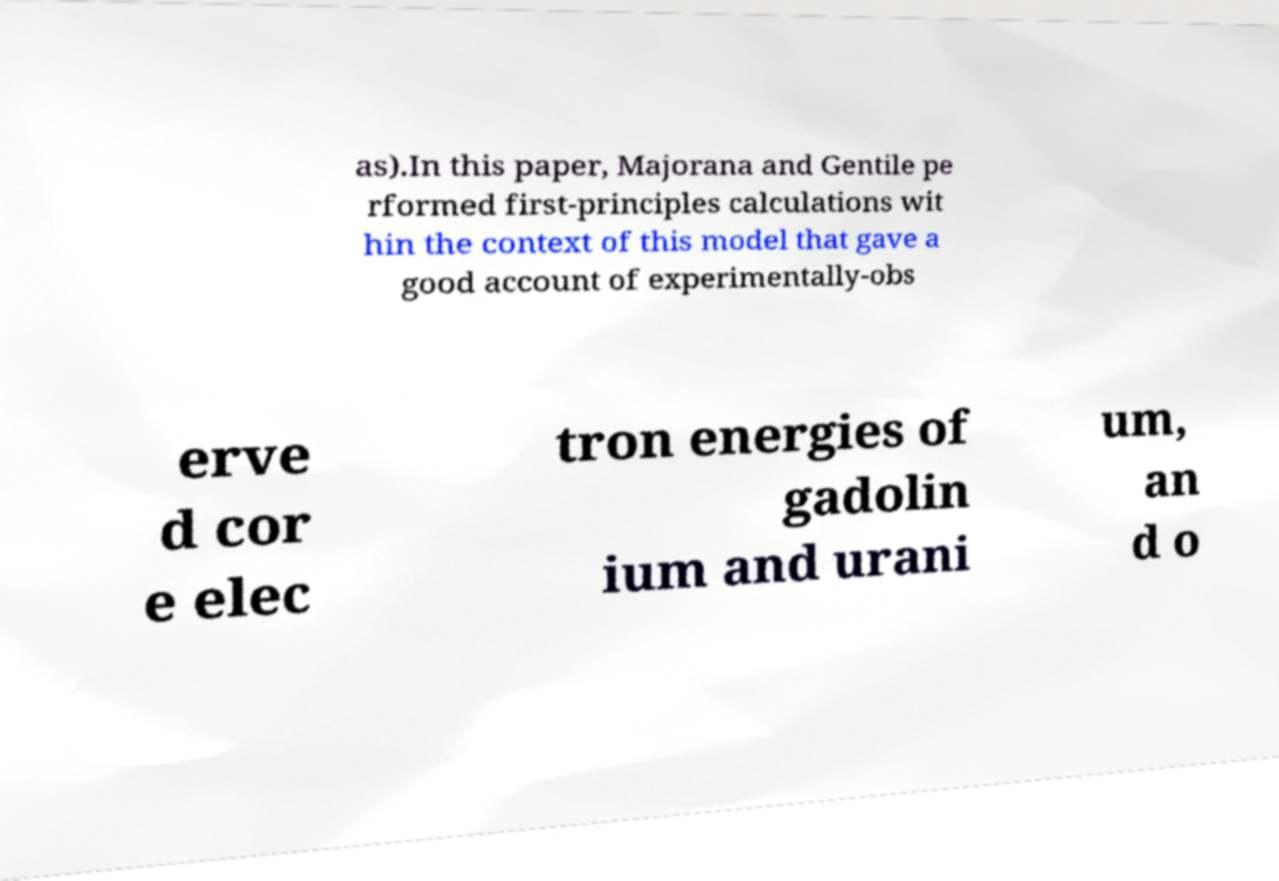Can you read and provide the text displayed in the image?This photo seems to have some interesting text. Can you extract and type it out for me? as).In this paper, Majorana and Gentile pe rformed first-principles calculations wit hin the context of this model that gave a good account of experimentally-obs erve d cor e elec tron energies of gadolin ium and urani um, an d o 